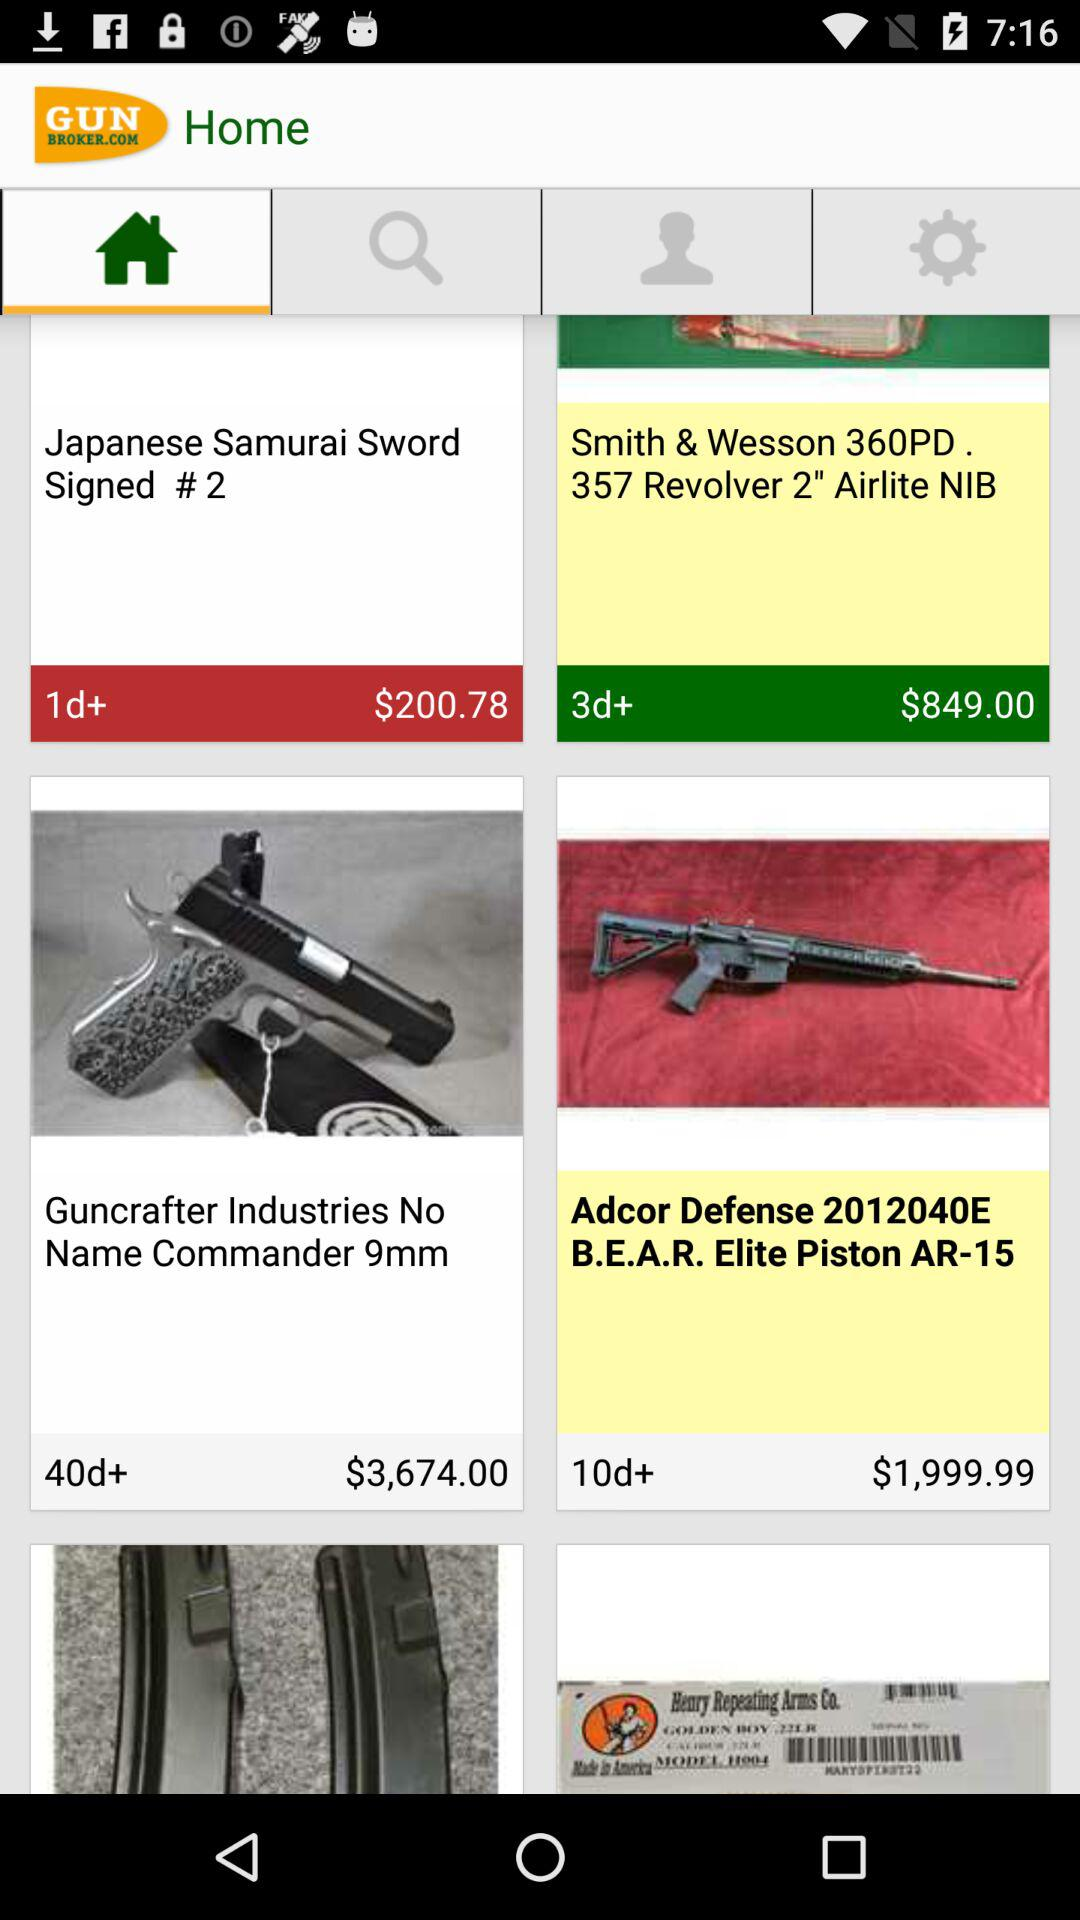Which tab is selected? The tab "Home" is selected. 